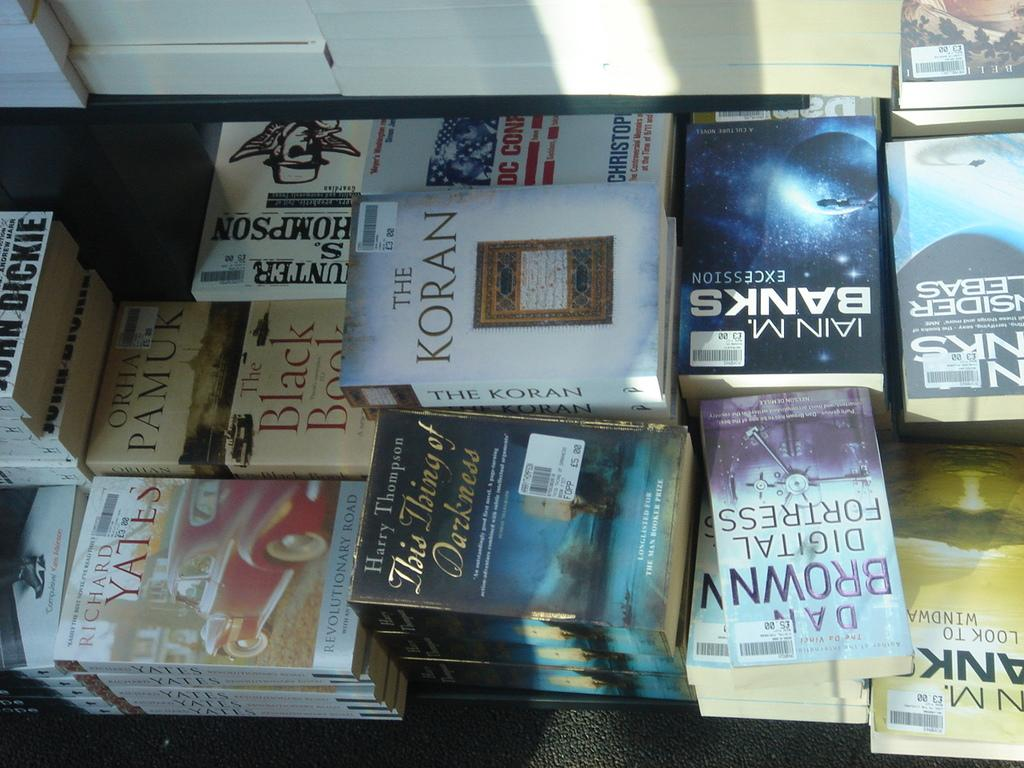<image>
Summarize the visual content of the image. The Koran sits on top of others books in a store setting 